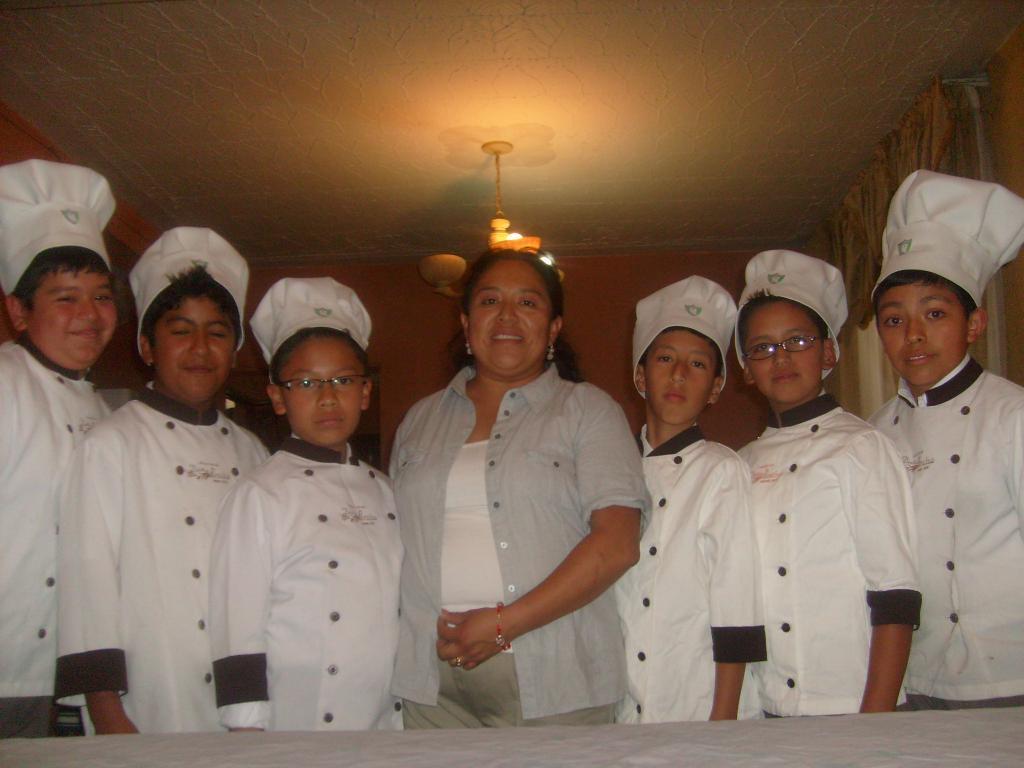How would you summarize this image in a sentence or two? In this image there are group of people who are wearing hats, and at the bottom it looks like a table. And in the background there is a wall and some objects, at the top there is ceiling and some object and it looks like a chandelier. 